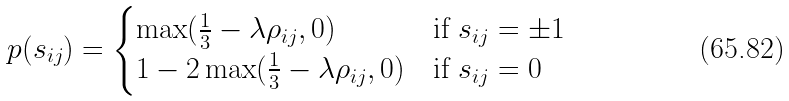Convert formula to latex. <formula><loc_0><loc_0><loc_500><loc_500>p ( s _ { i j } ) = \begin{cases} \max ( \frac { 1 } { 3 } - \lambda \rho _ { i j } , 0 ) & \text {if $s_{ij} = \pm 1$} \\ 1 - 2 \max ( \frac { 1 } { 3 } - \lambda \rho _ { i j } , 0 ) & \text {if $s_{ij} = 0$} \end{cases}</formula> 